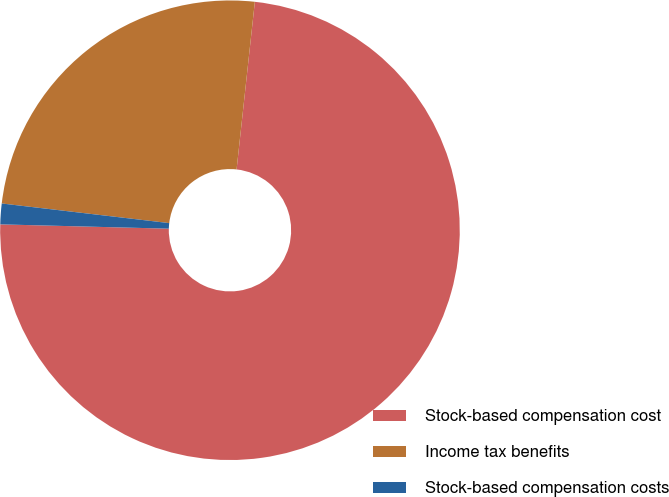Convert chart to OTSL. <chart><loc_0><loc_0><loc_500><loc_500><pie_chart><fcel>Stock-based compensation cost<fcel>Income tax benefits<fcel>Stock-based compensation costs<nl><fcel>73.68%<fcel>24.87%<fcel>1.45%<nl></chart> 